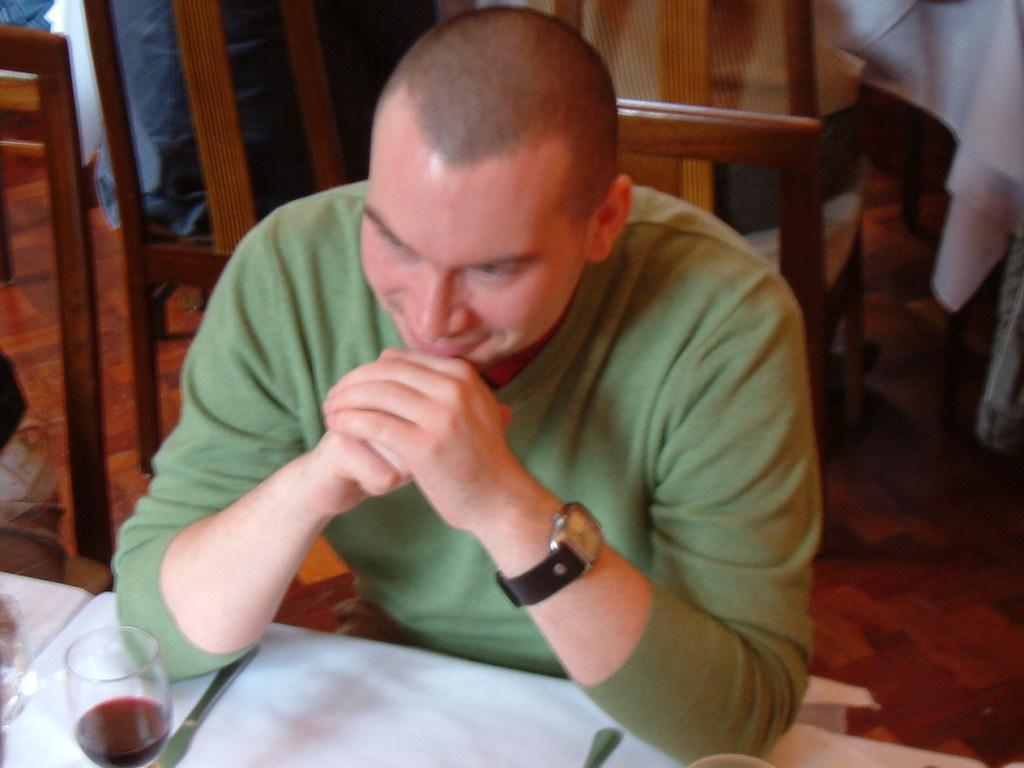Please provide a concise description of this image. This picture shows a man seated on the chair and we see a wine glass on the table 